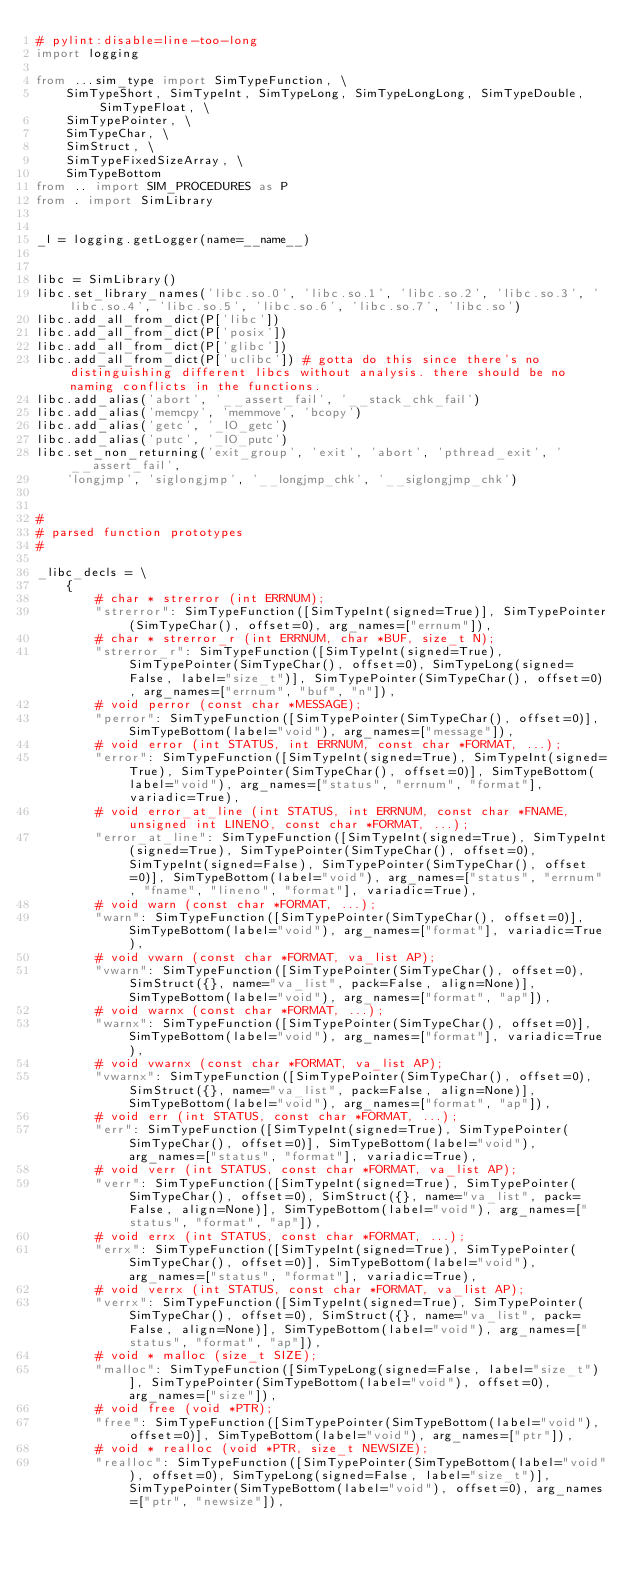<code> <loc_0><loc_0><loc_500><loc_500><_Python_># pylint:disable=line-too-long
import logging

from ...sim_type import SimTypeFunction, \
    SimTypeShort, SimTypeInt, SimTypeLong, SimTypeLongLong, SimTypeDouble, SimTypeFloat, \
    SimTypePointer, \
    SimTypeChar, \
    SimStruct, \
    SimTypeFixedSizeArray, \
    SimTypeBottom
from .. import SIM_PROCEDURES as P
from . import SimLibrary


_l = logging.getLogger(name=__name__)


libc = SimLibrary()
libc.set_library_names('libc.so.0', 'libc.so.1', 'libc.so.2', 'libc.so.3', 'libc.so.4', 'libc.so.5', 'libc.so.6', 'libc.so.7', 'libc.so')
libc.add_all_from_dict(P['libc'])
libc.add_all_from_dict(P['posix'])
libc.add_all_from_dict(P['glibc'])
libc.add_all_from_dict(P['uclibc']) # gotta do this since there's no distinguishing different libcs without analysis. there should be no naming conflicts in the functions.
libc.add_alias('abort', '__assert_fail', '__stack_chk_fail')
libc.add_alias('memcpy', 'memmove', 'bcopy')
libc.add_alias('getc', '_IO_getc')
libc.add_alias('putc', '_IO_putc')
libc.set_non_returning('exit_group', 'exit', 'abort', 'pthread_exit', '__assert_fail',
    'longjmp', 'siglongjmp', '__longjmp_chk', '__siglongjmp_chk')


#
# parsed function prototypes
#

_libc_decls = \
    {
        # char * strerror (int ERRNUM);
        "strerror": SimTypeFunction([SimTypeInt(signed=True)], SimTypePointer(SimTypeChar(), offset=0), arg_names=["errnum"]),
        # char * strerror_r (int ERRNUM, char *BUF, size_t N);
        "strerror_r": SimTypeFunction([SimTypeInt(signed=True), SimTypePointer(SimTypeChar(), offset=0), SimTypeLong(signed=False, label="size_t")], SimTypePointer(SimTypeChar(), offset=0), arg_names=["errnum", "buf", "n"]),
        # void perror (const char *MESSAGE);
        "perror": SimTypeFunction([SimTypePointer(SimTypeChar(), offset=0)], SimTypeBottom(label="void"), arg_names=["message"]),
        # void error (int STATUS, int ERRNUM, const char *FORMAT, ...);
        "error": SimTypeFunction([SimTypeInt(signed=True), SimTypeInt(signed=True), SimTypePointer(SimTypeChar(), offset=0)], SimTypeBottom(label="void"), arg_names=["status", "errnum", "format"], variadic=True),
        # void error_at_line (int STATUS, int ERRNUM, const char *FNAME, unsigned int LINENO, const char *FORMAT, ...);
        "error_at_line": SimTypeFunction([SimTypeInt(signed=True), SimTypeInt(signed=True), SimTypePointer(SimTypeChar(), offset=0), SimTypeInt(signed=False), SimTypePointer(SimTypeChar(), offset=0)], SimTypeBottom(label="void"), arg_names=["status", "errnum", "fname", "lineno", "format"], variadic=True),
        # void warn (const char *FORMAT, ...);
        "warn": SimTypeFunction([SimTypePointer(SimTypeChar(), offset=0)], SimTypeBottom(label="void"), arg_names=["format"], variadic=True),
        # void vwarn (const char *FORMAT, va_list AP);
        "vwarn": SimTypeFunction([SimTypePointer(SimTypeChar(), offset=0), SimStruct({}, name="va_list", pack=False, align=None)], SimTypeBottom(label="void"), arg_names=["format", "ap"]),
        # void warnx (const char *FORMAT, ...);
        "warnx": SimTypeFunction([SimTypePointer(SimTypeChar(), offset=0)], SimTypeBottom(label="void"), arg_names=["format"], variadic=True),
        # void vwarnx (const char *FORMAT, va_list AP);
        "vwarnx": SimTypeFunction([SimTypePointer(SimTypeChar(), offset=0), SimStruct({}, name="va_list", pack=False, align=None)], SimTypeBottom(label="void"), arg_names=["format", "ap"]),
        # void err (int STATUS, const char *FORMAT, ...);
        "err": SimTypeFunction([SimTypeInt(signed=True), SimTypePointer(SimTypeChar(), offset=0)], SimTypeBottom(label="void"), arg_names=["status", "format"], variadic=True),
        # void verr (int STATUS, const char *FORMAT, va_list AP);
        "verr": SimTypeFunction([SimTypeInt(signed=True), SimTypePointer(SimTypeChar(), offset=0), SimStruct({}, name="va_list", pack=False, align=None)], SimTypeBottom(label="void"), arg_names=["status", "format", "ap"]),
        # void errx (int STATUS, const char *FORMAT, ...);
        "errx": SimTypeFunction([SimTypeInt(signed=True), SimTypePointer(SimTypeChar(), offset=0)], SimTypeBottom(label="void"), arg_names=["status", "format"], variadic=True),
        # void verrx (int STATUS, const char *FORMAT, va_list AP);
        "verrx": SimTypeFunction([SimTypeInt(signed=True), SimTypePointer(SimTypeChar(), offset=0), SimStruct({}, name="va_list", pack=False, align=None)], SimTypeBottom(label="void"), arg_names=["status", "format", "ap"]),
        # void * malloc (size_t SIZE);
        "malloc": SimTypeFunction([SimTypeLong(signed=False, label="size_t")], SimTypePointer(SimTypeBottom(label="void"), offset=0), arg_names=["size"]),
        # void free (void *PTR);
        "free": SimTypeFunction([SimTypePointer(SimTypeBottom(label="void"), offset=0)], SimTypeBottom(label="void"), arg_names=["ptr"]),
        # void * realloc (void *PTR, size_t NEWSIZE);
        "realloc": SimTypeFunction([SimTypePointer(SimTypeBottom(label="void"), offset=0), SimTypeLong(signed=False, label="size_t")], SimTypePointer(SimTypeBottom(label="void"), offset=0), arg_names=["ptr", "newsize"]),</code> 